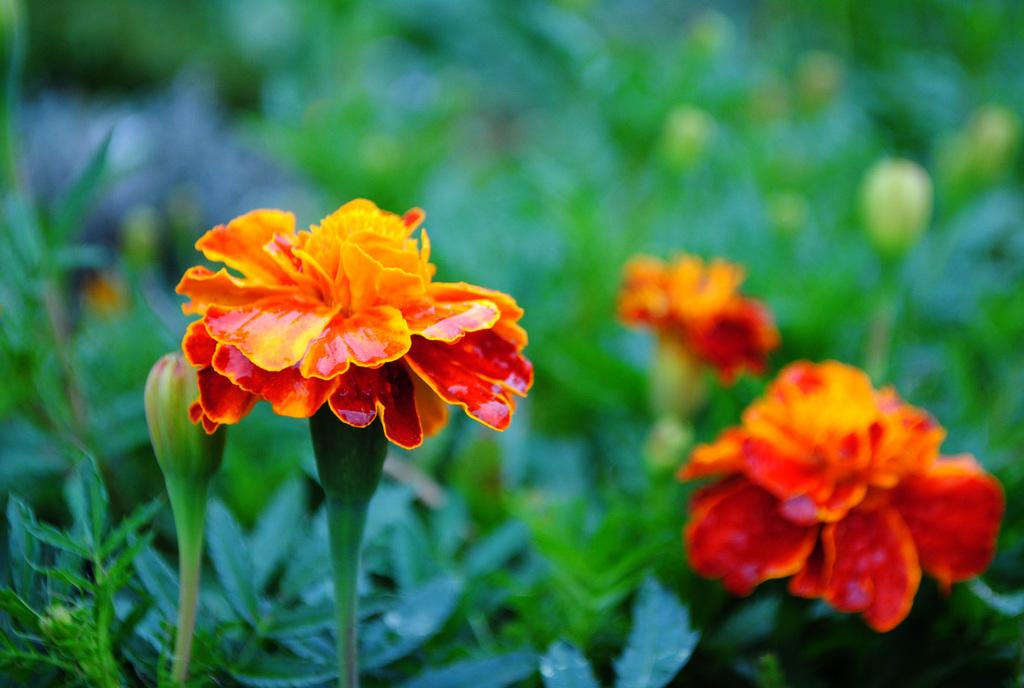What color are the flowers on the plant in the image? The flowers on the plant are orange in color. What stage of growth are some of the flowers in? There are buds on the plant, indicating that some flowers are not yet fully bloomed. What can be found at the base of the plant? There are leaves at the bottom of the plant. What type of cloth is draped over the queen's throne in the image? There is no queen, throne, or cloth present in the image; it features a plant with orange flowers, buds, and leaves. 